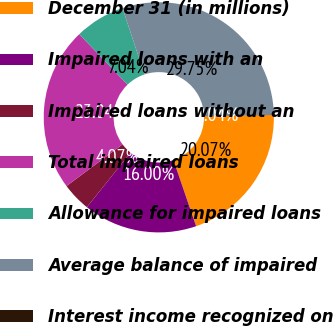Convert chart. <chart><loc_0><loc_0><loc_500><loc_500><pie_chart><fcel>December 31 (in millions)<fcel>Impaired loans with an<fcel>Impaired loans without an<fcel>Total impaired loans<fcel>Allowance for impaired loans<fcel>Average balance of impaired<fcel>Interest income recognized on<nl><fcel>20.07%<fcel>16.0%<fcel>4.07%<fcel>23.04%<fcel>7.04%<fcel>29.75%<fcel>0.04%<nl></chart> 